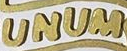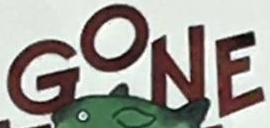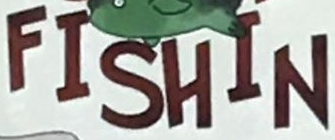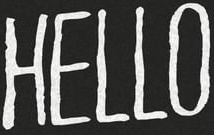Read the text content from these images in order, separated by a semicolon. UNUM; GONE; FISHIN; HELLO 